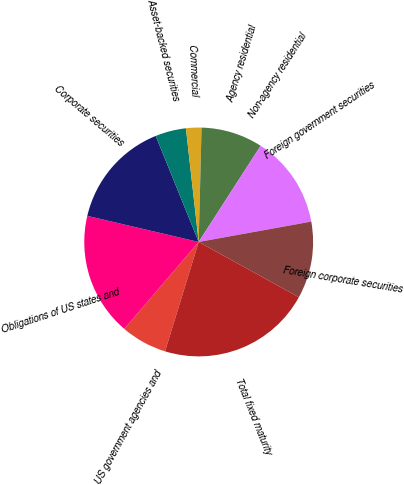Convert chart. <chart><loc_0><loc_0><loc_500><loc_500><pie_chart><fcel>US government agencies and<fcel>Obligations of US states and<fcel>Corporate securities<fcel>Asset-backed securities<fcel>Commercial<fcel>Agency residential<fcel>Non-agency residential<fcel>Foreign government securities<fcel>Foreign corporate securities<fcel>Total fixed maturity<nl><fcel>6.52%<fcel>17.39%<fcel>15.21%<fcel>4.35%<fcel>2.18%<fcel>8.7%<fcel>0.01%<fcel>13.04%<fcel>10.87%<fcel>21.73%<nl></chart> 